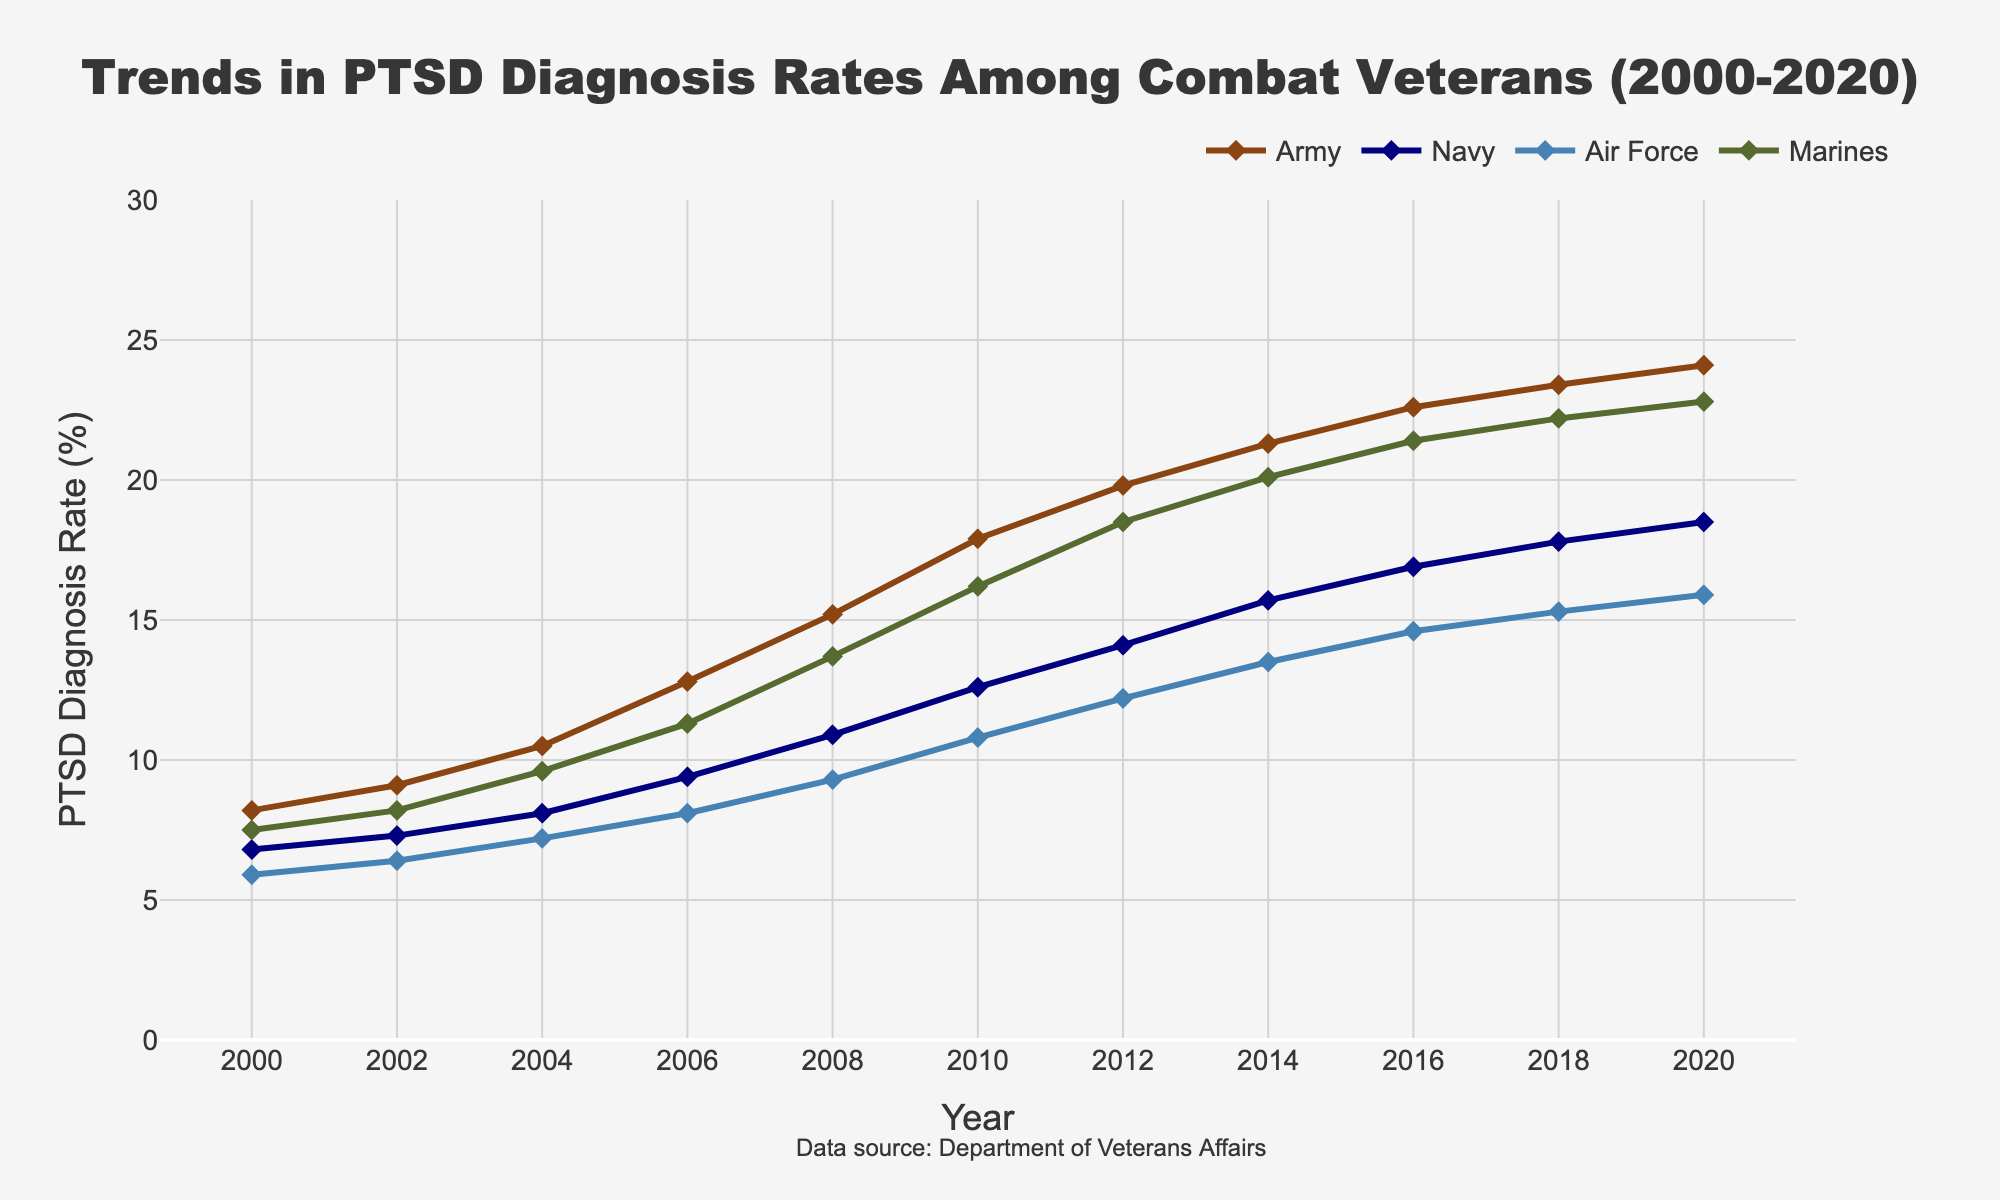What is the overall trend in PTSD diagnosis rates among all branches from 2000 to 2020? From the figure, you can see that the PTSD diagnosis rates for all branches see a general upward trend from 2000 to 2020, indicating an increase in diagnoses over time. This upward trend is observed for the Army, Navy, Air Force, and Marines.
Answer: Increasing Which branch had the highest PTSD diagnosis rate in 2020? Looking at the data points for the year 2020, the Army has the highest rate at 24.1%, followed by the Marines, Navy, and Air Force.
Answer: Army Compare the growth rate of PTSD diagnoses in the Marines and the Air Force from 2000 to 2020. The rate for the Marines increased from 7.5% in 2000 to 22.8% in 2020, a difference of 15.3 percentage points. For the Air Force, it grew from 5.9% to 15.9%, a difference of 10 percentage points. Hence, the Marines saw a higher growth rate.
Answer: Marines What was the average PTSD diagnosis rate across all branches in 2010? To find the average PTSD diagnosis rate in 2010, sum the rates for all branches and divide by the number of branches: (17.9 + 12.6 + 10.8 + 16.2) / 4 = 14.375%.
Answer: 14.375% Which branch showed the most significant increase in PTSD diagnosis rates between 2000 and 2010? By calculating the difference between the 2010 and 2000 rates for each branch: Army (17.9-8.2=9.7), Navy (12.6-6.8=5.8), Air Force (10.8-5.9=4.9), Marines (16.2-7.5=8.7). The Army shows the most significant increase.
Answer: Army What is the difference in PTSD diagnosis rates between the Army and Navy in 2014? The rate in 2014 for the Army is 21.3%, and for the Navy, it’s 15.7%. The difference is 21.3 - 15.7 = 5.6 percentage points.
Answer: 5.6 percentage points Which branch has consistently shown the lowest rate of PTSD diagnoses from 2000 to 2020? Observing the figure, the Air Force consistently has the lowest rates compared to the other branches throughout the years.
Answer: Air Force Identify the year with the highest increase in PTSD diagnosis rates across any branch. Which branch was it? Plotting the differences between consecutive years for each branch, the Army shows the highest increase between 2006 (12.8) and 2008 (15.2), an increase of 2.4 percentage points.
Answer: Army (2006 to 2008) What were the PTSD diagnosis rates for the Navy and Marines in 2008, and which branch had a higher rate? In 2008, the Navy’s rate is 10.9%, and the Marines' rate is 13.7%. The Marines had the higher rate.
Answer: Marines Calculate the overall increase in PTSD diagnosis rates for the Navy from 2000 to 2020. The rate for the Navy in 2000 is 6.8%, and in 2020 it is 18.5%. The overall increase is 18.5 - 6.8 = 11.7 percentage points.
Answer: 11.7 percentage points 